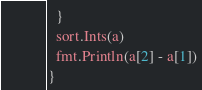<code> <loc_0><loc_0><loc_500><loc_500><_Go_>  }
  sort.Ints(a)
  fmt.Println(a[2] - a[1])
}
</code> 